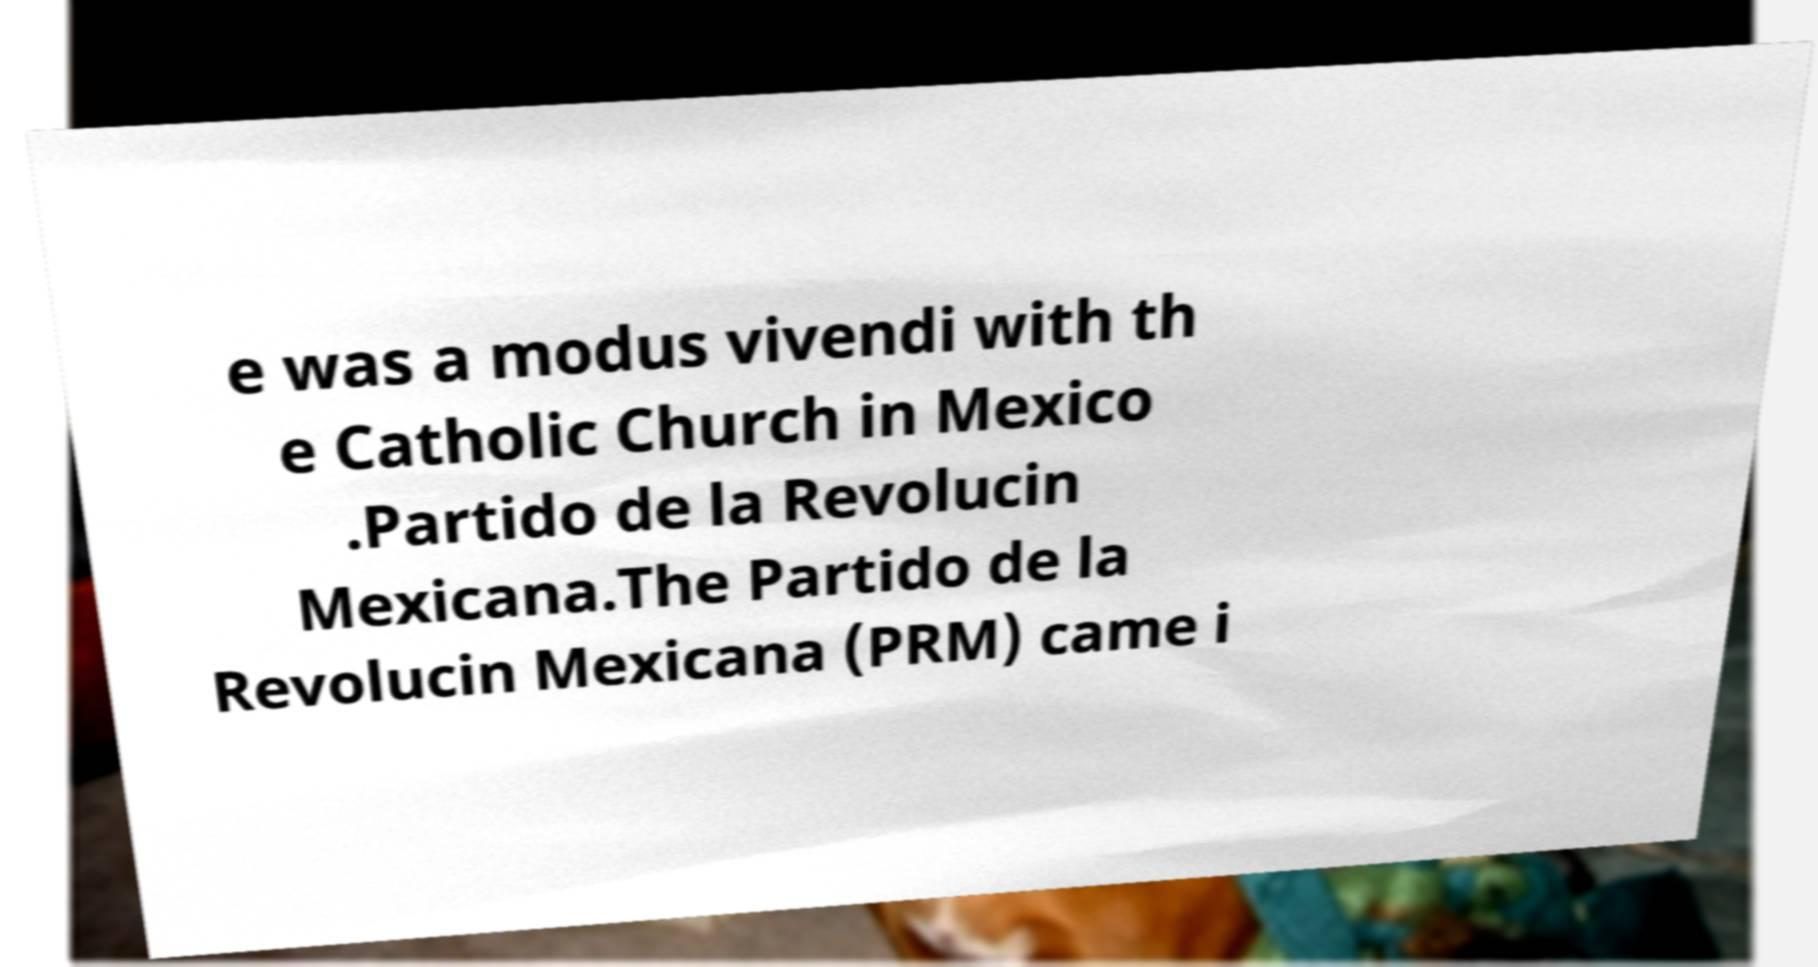Could you extract and type out the text from this image? e was a modus vivendi with th e Catholic Church in Mexico .Partido de la Revolucin Mexicana.The Partido de la Revolucin Mexicana (PRM) came i 